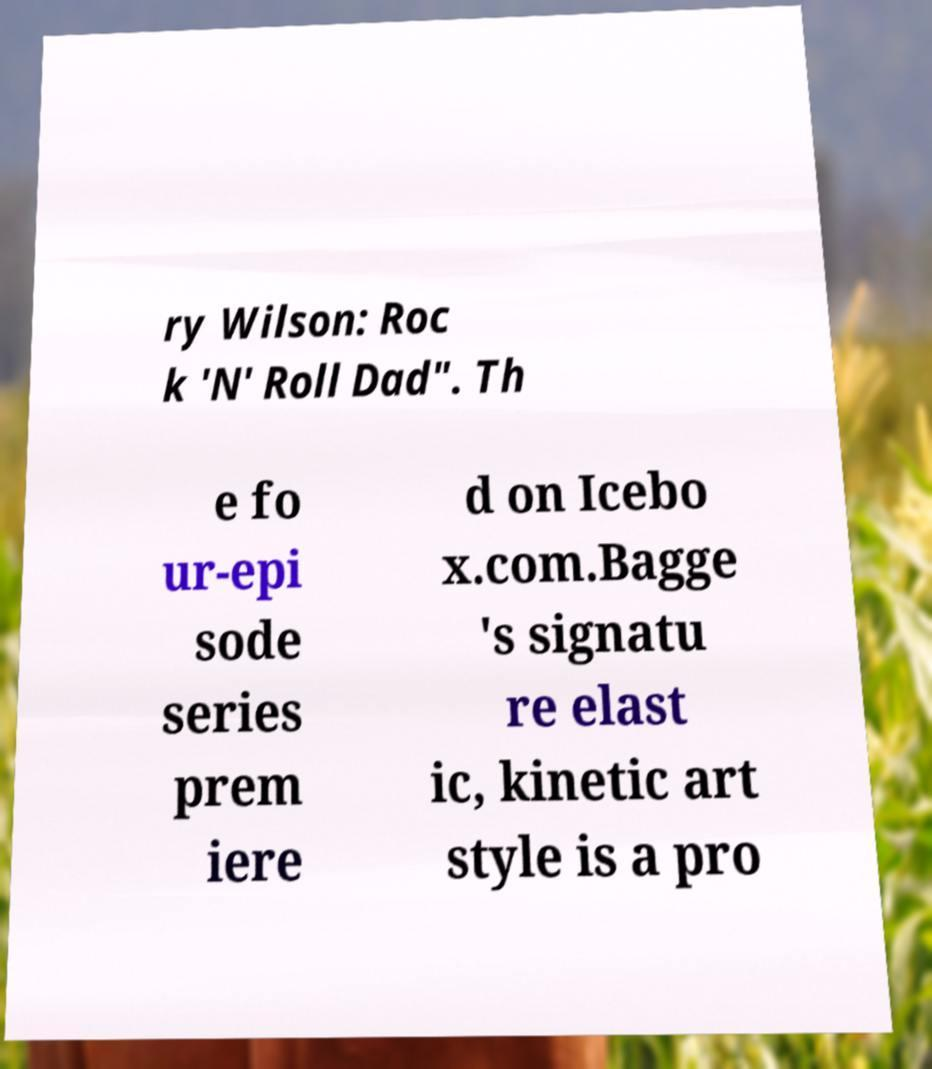I need the written content from this picture converted into text. Can you do that? ry Wilson: Roc k 'N' Roll Dad". Th e fo ur-epi sode series prem iere d on Icebo x.com.Bagge 's signatu re elast ic, kinetic art style is a pro 